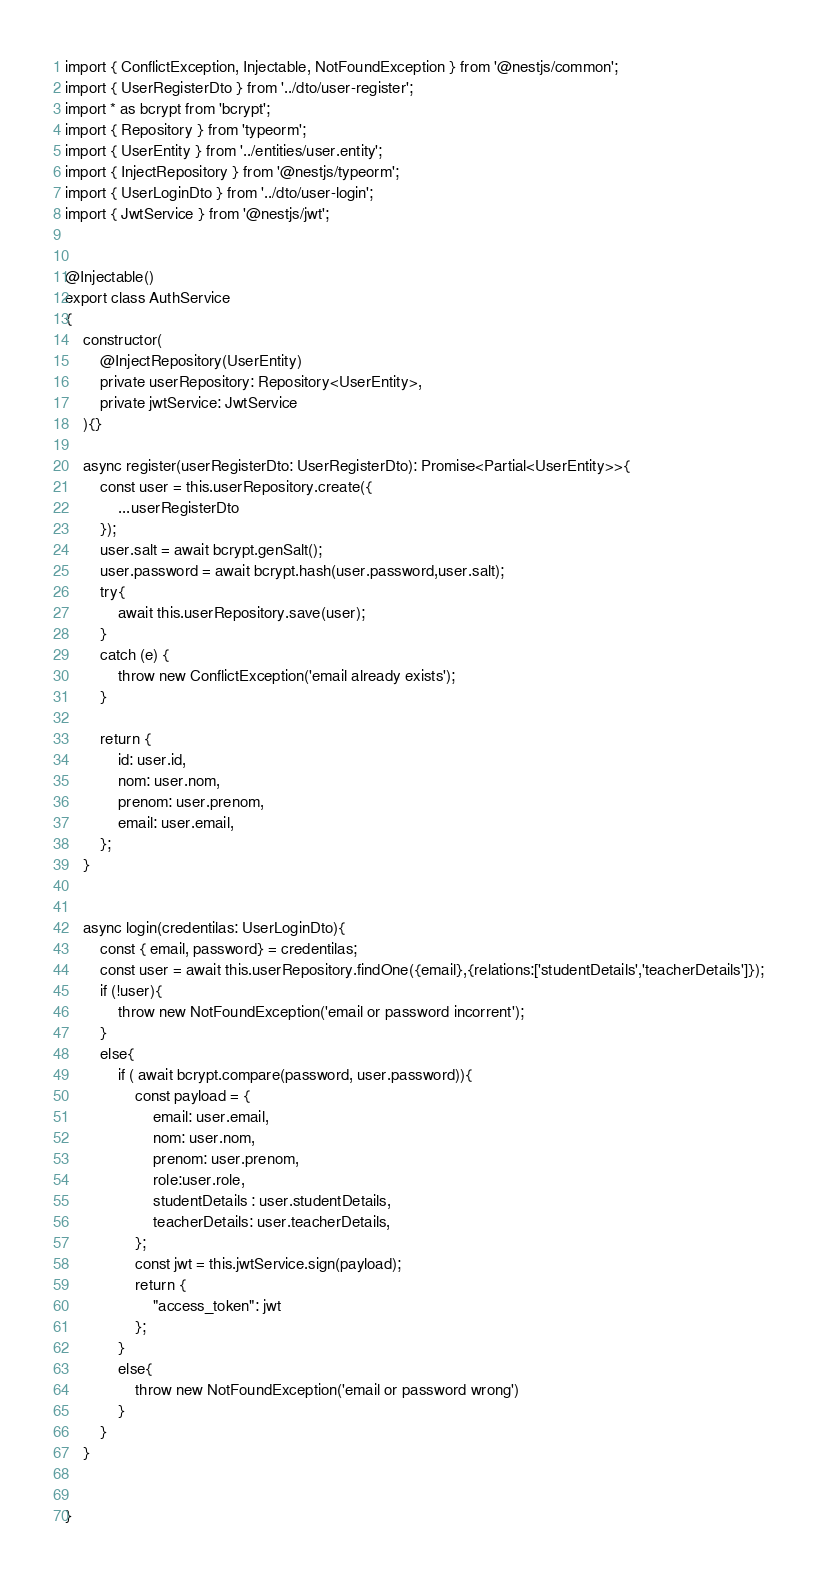<code> <loc_0><loc_0><loc_500><loc_500><_TypeScript_>import { ConflictException, Injectable, NotFoundException } from '@nestjs/common';
import { UserRegisterDto } from '../dto/user-register';
import * as bcrypt from 'bcrypt';
import { Repository } from 'typeorm';
import { UserEntity } from '../entities/user.entity';
import { InjectRepository } from '@nestjs/typeorm';
import { UserLoginDto } from '../dto/user-login';
import { JwtService } from '@nestjs/jwt';


@Injectable()
export class AuthService 
{
    constructor(
        @InjectRepository(UserEntity)
        private userRepository: Repository<UserEntity>,
        private jwtService: JwtService
    ){}

    async register(userRegisterDto: UserRegisterDto): Promise<Partial<UserEntity>>{
        const user = this.userRepository.create({
            ...userRegisterDto
        });
        user.salt = await bcrypt.genSalt();
        user.password = await bcrypt.hash(user.password,user.salt);
        try{
            await this.userRepository.save(user);
        }
        catch (e) {
            throw new ConflictException('email already exists');
        }

        return {
            id: user.id,
            nom: user.nom,
            prenom: user.prenom,
            email: user.email,
        };
    }


    async login(credentilas: UserLoginDto){
        const { email, password} = credentilas;
        const user = await this.userRepository.findOne({email},{relations:['studentDetails','teacherDetails']});
        if (!user){
            throw new NotFoundException('email or password incorrent');
        }
        else{
            if ( await bcrypt.compare(password, user.password)){
                const payload = {
                    email: user.email,
                    nom: user.nom,
                    prenom: user.prenom,
                    role:user.role,
                    studentDetails : user.studentDetails,
                    teacherDetails: user.teacherDetails,
                };
                const jwt = this.jwtService.sign(payload);
                return { 
                    "access_token": jwt
                };
            }
            else{
                throw new NotFoundException('email or password wrong')
            }
        }
    }


}
</code> 